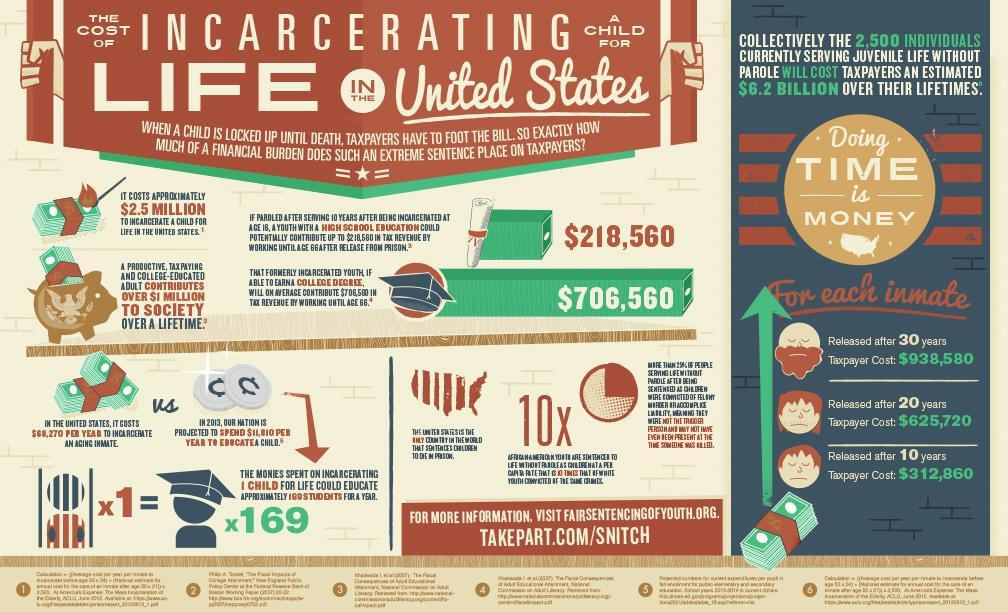how much do taxpayers need to pay the 2,500 individuals
Answer the question with a short phrase. $6.2 billion what will be the tax revenue for a incarcenated youth with college degree $706,560 what is lifetime contribution of a college educated tax paying adult $1 million educating 169 students for a year is equal to what? the monies spent on incarcerating 1 child what is the projected education cost per child in 2013 $11,810 